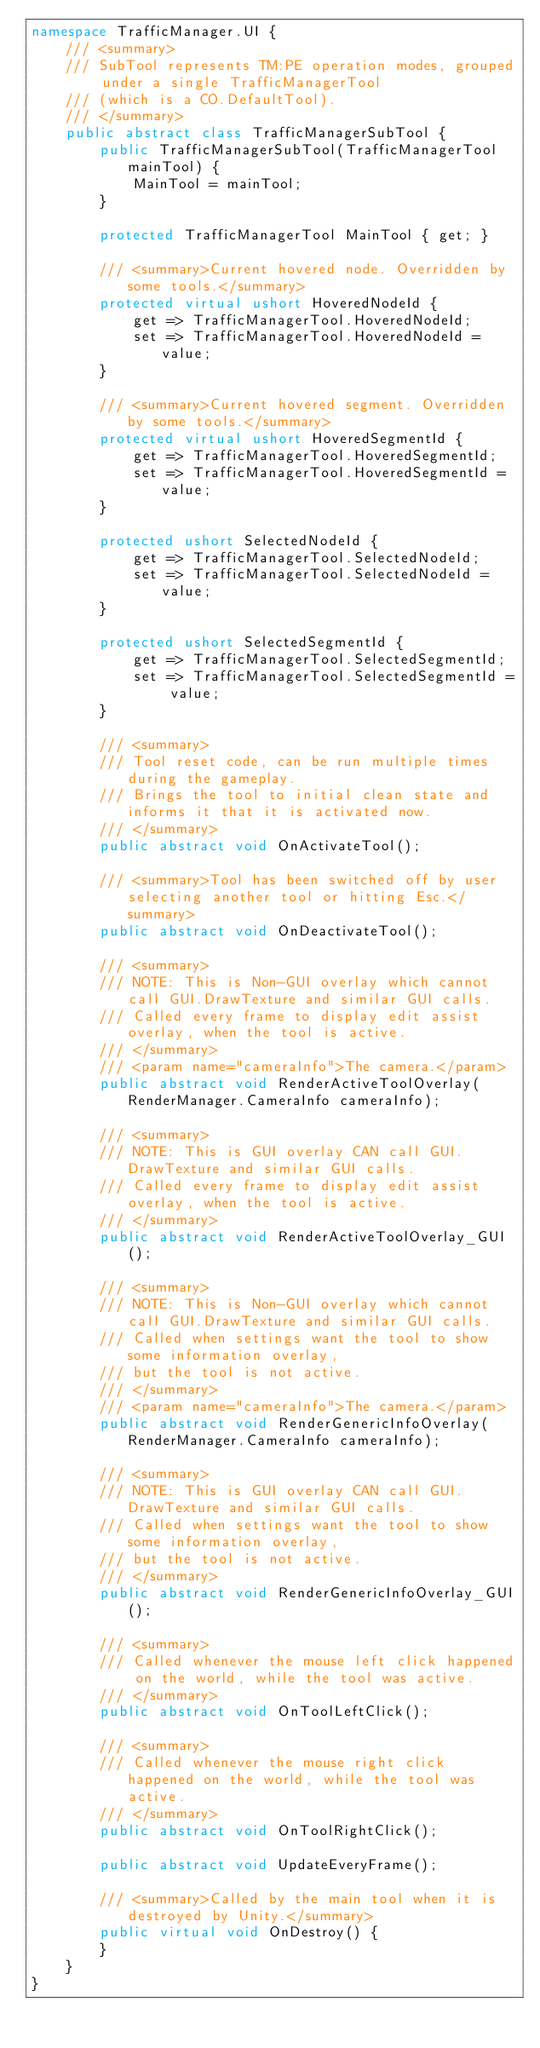<code> <loc_0><loc_0><loc_500><loc_500><_C#_>namespace TrafficManager.UI {
    /// <summary>
    /// SubTool represents TM:PE operation modes, grouped under a single TrafficManagerTool
    /// (which is a CO.DefaultTool).
    /// </summary>
    public abstract class TrafficManagerSubTool {
        public TrafficManagerSubTool(TrafficManagerTool mainTool) {
            MainTool = mainTool;
        }

        protected TrafficManagerTool MainTool { get; }

        /// <summary>Current hovered node. Overridden by some tools.</summary>
        protected virtual ushort HoveredNodeId {
            get => TrafficManagerTool.HoveredNodeId;
            set => TrafficManagerTool.HoveredNodeId = value;
        }

        /// <summary>Current hovered segment. Overridden by some tools.</summary>
        protected virtual ushort HoveredSegmentId {
            get => TrafficManagerTool.HoveredSegmentId;
            set => TrafficManagerTool.HoveredSegmentId = value;
        }

        protected ushort SelectedNodeId {
            get => TrafficManagerTool.SelectedNodeId;
            set => TrafficManagerTool.SelectedNodeId = value;
        }

        protected ushort SelectedSegmentId {
            get => TrafficManagerTool.SelectedSegmentId;
            set => TrafficManagerTool.SelectedSegmentId = value;
        }

        /// <summary>
        /// Tool reset code, can be run multiple times during the gameplay.
        /// Brings the tool to initial clean state and informs it that it is activated now.
        /// </summary>
        public abstract void OnActivateTool();

        /// <summary>Tool has been switched off by user selecting another tool or hitting Esc.</summary>
        public abstract void OnDeactivateTool();

        /// <summary>
        /// NOTE: This is Non-GUI overlay which cannot call GUI.DrawTexture and similar GUI calls.
        /// Called every frame to display edit assist overlay, when the tool is active.
        /// </summary>
        /// <param name="cameraInfo">The camera.</param>
        public abstract void RenderActiveToolOverlay(RenderManager.CameraInfo cameraInfo);

        /// <summary>
        /// NOTE: This is GUI overlay CAN call GUI.DrawTexture and similar GUI calls.
        /// Called every frame to display edit assist overlay, when the tool is active.
        /// </summary>
        public abstract void RenderActiveToolOverlay_GUI();

        /// <summary>
        /// NOTE: This is Non-GUI overlay which cannot call GUI.DrawTexture and similar GUI calls.
        /// Called when settings want the tool to show some information overlay,
        /// but the tool is not active.
        /// </summary>
        /// <param name="cameraInfo">The camera.</param>
        public abstract void RenderGenericInfoOverlay(RenderManager.CameraInfo cameraInfo);

        /// <summary>
        /// NOTE: This is GUI overlay CAN call GUI.DrawTexture and similar GUI calls.
        /// Called when settings want the tool to show some information overlay,
        /// but the tool is not active.
        /// </summary>
        public abstract void RenderGenericInfoOverlay_GUI();

        /// <summary>
        /// Called whenever the mouse left click happened on the world, while the tool was active.
        /// </summary>
        public abstract void OnToolLeftClick();

        /// <summary>
        /// Called whenever the mouse right click happened on the world, while the tool was active.
        /// </summary>
        public abstract void OnToolRightClick();

        public abstract void UpdateEveryFrame();

        /// <summary>Called by the main tool when it is destroyed by Unity.</summary>
        public virtual void OnDestroy() {
        }
    }
}</code> 